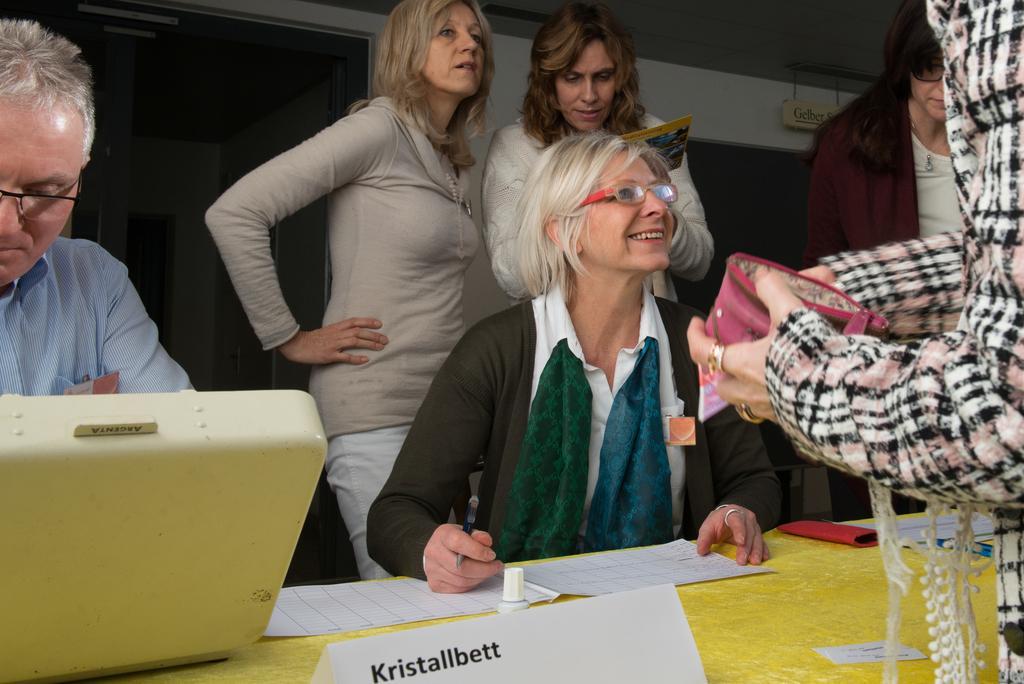Could you give a brief overview of what you see in this image? In this picture we can see a group of people, in front of them we can see a platform, papers and some objects and in the background we can see a roof and some objects. 